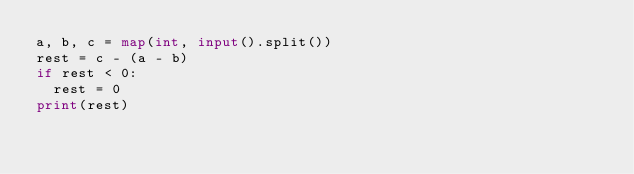Convert code to text. <code><loc_0><loc_0><loc_500><loc_500><_Python_>a, b, c = map(int, input().split())
rest = c - (a - b)
if rest < 0:
  rest = 0
print(rest)</code> 